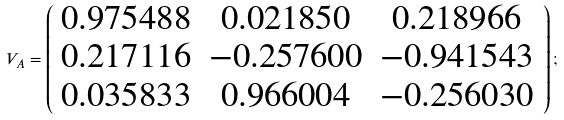Convert formula to latex. <formula><loc_0><loc_0><loc_500><loc_500>V _ { A } = \left ( \begin{array} { c c c } 0 . 9 7 5 4 8 8 & 0 . 0 2 1 8 5 0 & 0 . 2 1 8 9 6 6 \\ 0 . 2 1 7 1 1 6 & - 0 . 2 5 7 6 0 0 & - 0 . 9 4 1 5 4 3 \\ 0 . 0 3 5 8 3 3 & 0 . 9 6 6 0 0 4 & - 0 . 2 5 6 0 3 0 \\ \end{array} \right ) ;</formula> 